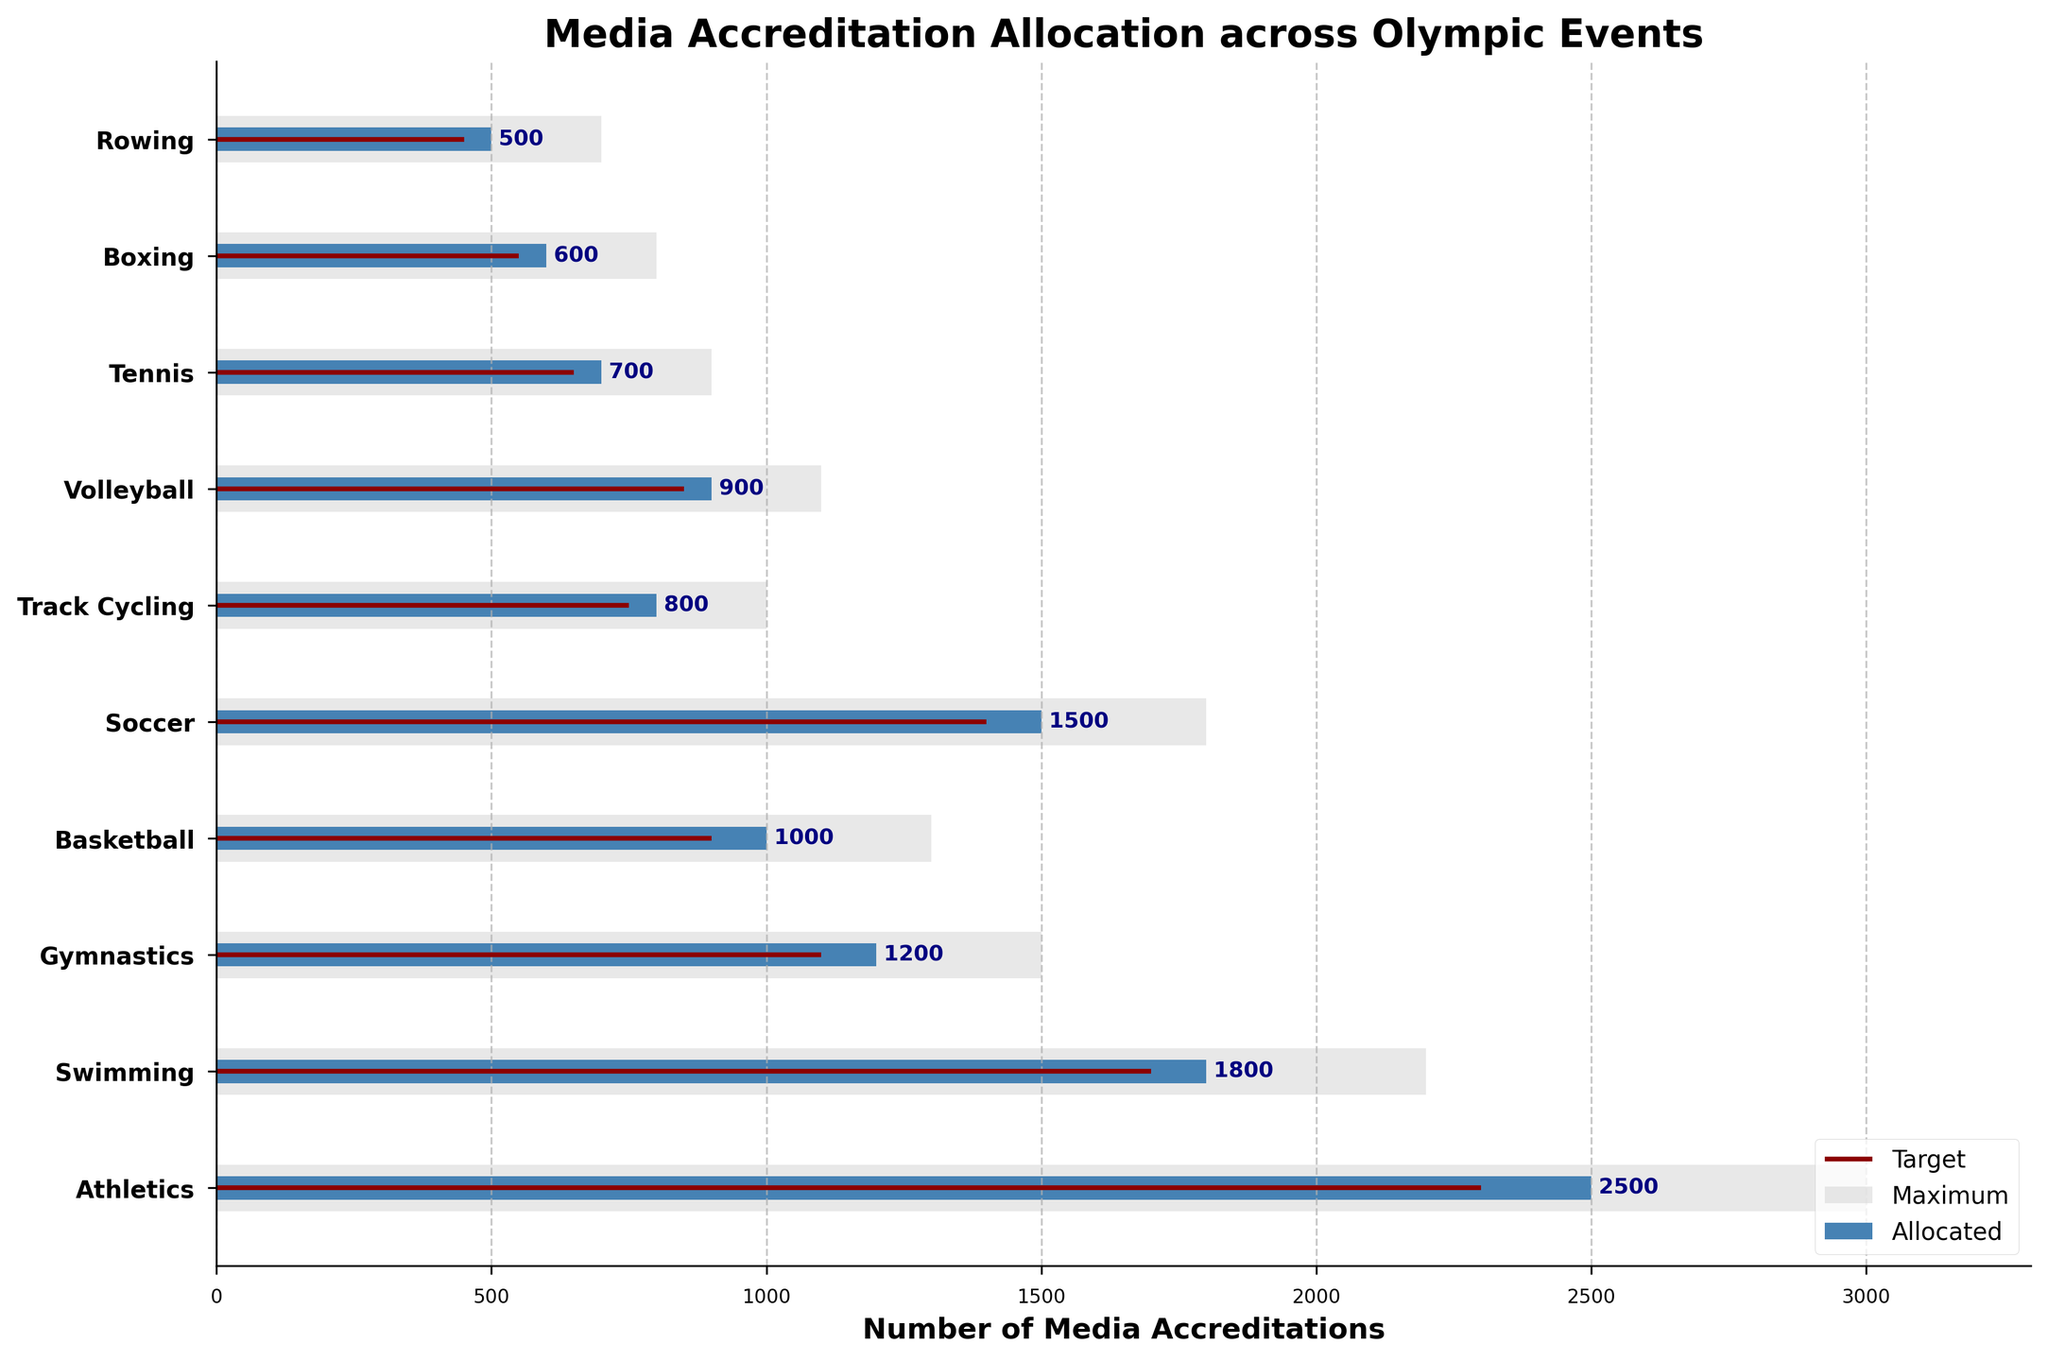What is the title of the figure? The title of the figure is displayed prominently at the top, indicating what the chart is about.
Answer: Media Accreditation Allocation across Olympic Events Which event has the highest number of allocated media accreditations? We need to look at the bar that extends the furthest to the right within the Allocated category, which is Athletics.
Answer: Athletics How many media accreditations were allocated for Gymnastics? The allocated bar for Gymnastics reaches up to 1200, as noted by the label on the bar.
Answer: 1200 What is the target number of media accreditations for Swimming? The dark red target line for Swimming indicates the target number, which reaches up to 1700.
Answer: 1700 Which event's allocated accreditations most closely match its target? By comparing the lengths of the allocated bars to the target lines, Track Cycling has its allocated accreditations (800) very close to its target (750).
Answer: Track Cycling For which event is the gap between allocated and maximum media accreditations the largest? We need to subtract the Allocated value from the Maximum value for all events. Athletics has the gap of 3000 - 2500 = 500, which is the largest.
Answer: Athletics How many more media accreditations were allocated to Soccer compared to Rowing? We must subtract the allocated value of Rowing from Soccer, which is 1500 - 500 = 1000.
Answer: 1000 What percentage of the maximum media accreditations was allocated to Volleyball? The allocated amount for Volleyball is 900, with a maximum of 1100. The percentage is calculated as (900/1100) * 100 = 81.82%.
Answer: 81.82% Which events have more than 1000 allocated media accreditations? By looking at the length of the allocated bars, the events with more than 1000 allocated accreditations are Athletics, Swimming, Gymnastics, and Soccer.
Answer: Athletics, Swimming, Gymnastics, Soccer What is the difference between the target and allocated media accreditations for Boxing? The target for Boxing is 550, and the allocated is 600. The difference is 600 - 550 = 50.
Answer: 50 